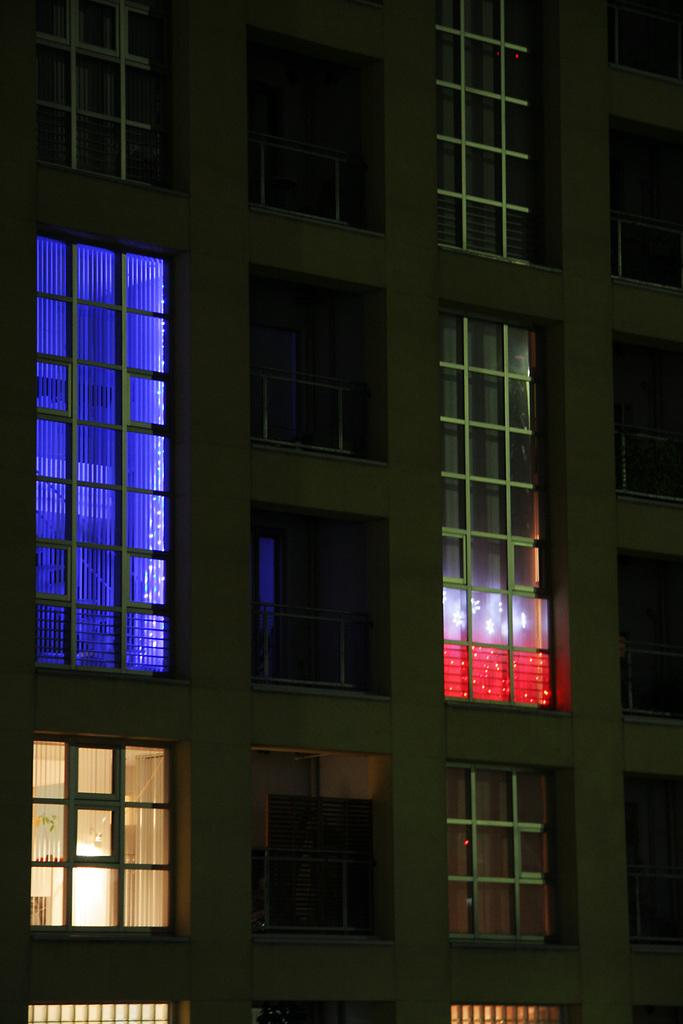What type of structure is visible in the image? There is a building in the image. What architectural feature can be seen on the building? There are windows visible in the image. Can you see a family of birds flying around the building in the image? There is no mention of birds or a family of birds in the image; it only features a building with windows. 